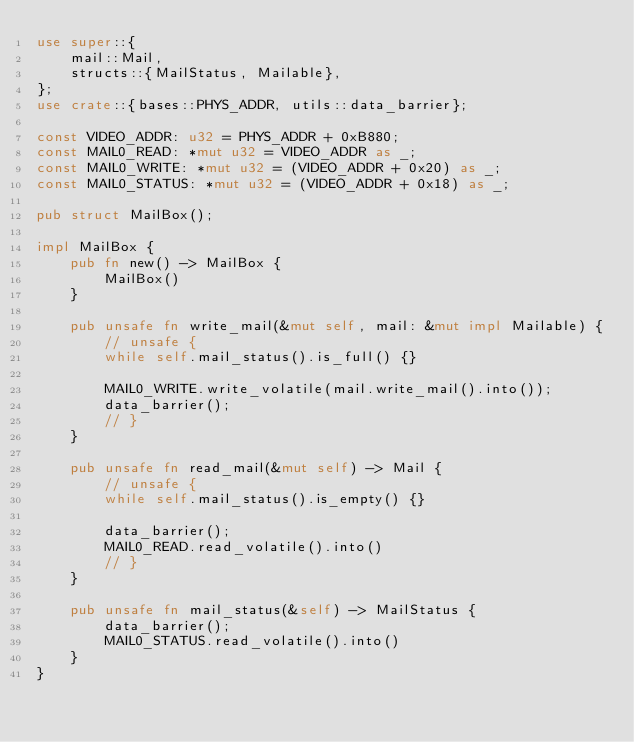Convert code to text. <code><loc_0><loc_0><loc_500><loc_500><_Rust_>use super::{
    mail::Mail,
    structs::{MailStatus, Mailable},
};
use crate::{bases::PHYS_ADDR, utils::data_barrier};

const VIDEO_ADDR: u32 = PHYS_ADDR + 0xB880;
const MAIL0_READ: *mut u32 = VIDEO_ADDR as _;
const MAIL0_WRITE: *mut u32 = (VIDEO_ADDR + 0x20) as _;
const MAIL0_STATUS: *mut u32 = (VIDEO_ADDR + 0x18) as _;

pub struct MailBox();

impl MailBox {
    pub fn new() -> MailBox {
        MailBox()
    }

    pub unsafe fn write_mail(&mut self, mail: &mut impl Mailable) {
        // unsafe {
        while self.mail_status().is_full() {}

        MAIL0_WRITE.write_volatile(mail.write_mail().into());
        data_barrier();
        // }
    }

    pub unsafe fn read_mail(&mut self) -> Mail {
        // unsafe {
        while self.mail_status().is_empty() {}

        data_barrier();
        MAIL0_READ.read_volatile().into()
        // }
    }

    pub unsafe fn mail_status(&self) -> MailStatus {
        data_barrier();
        MAIL0_STATUS.read_volatile().into()
    }
}
</code> 